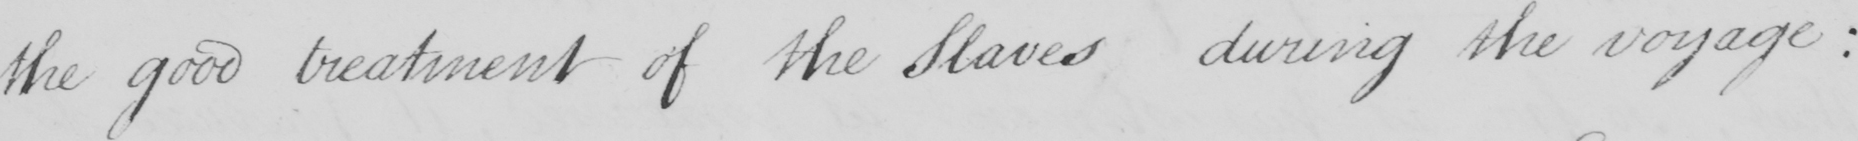What does this handwritten line say? the good treatment of the Slaves during the voyage  : 